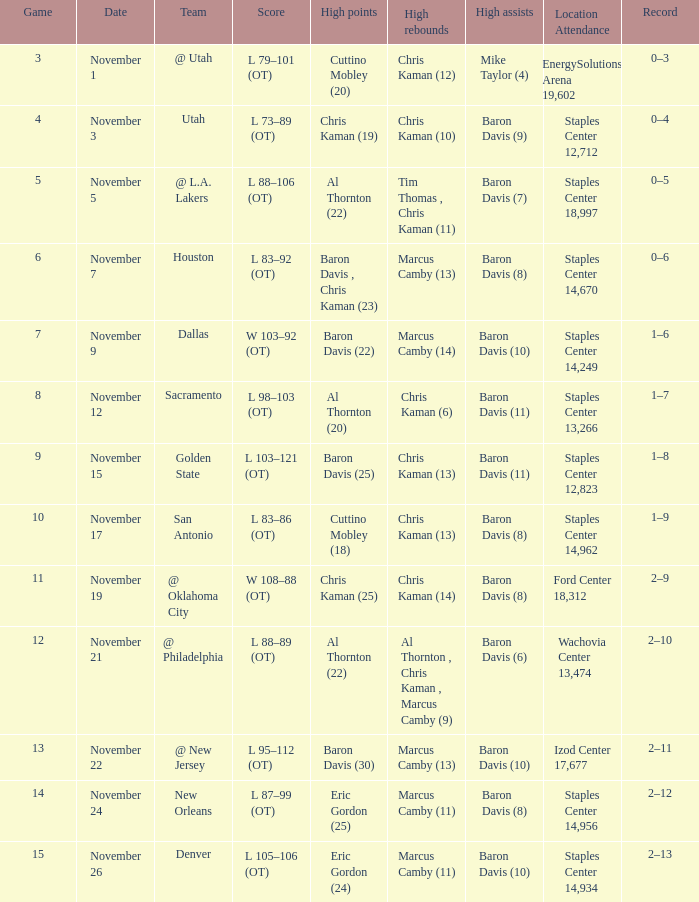Name the total number of score for staples center 13,266 1.0. 